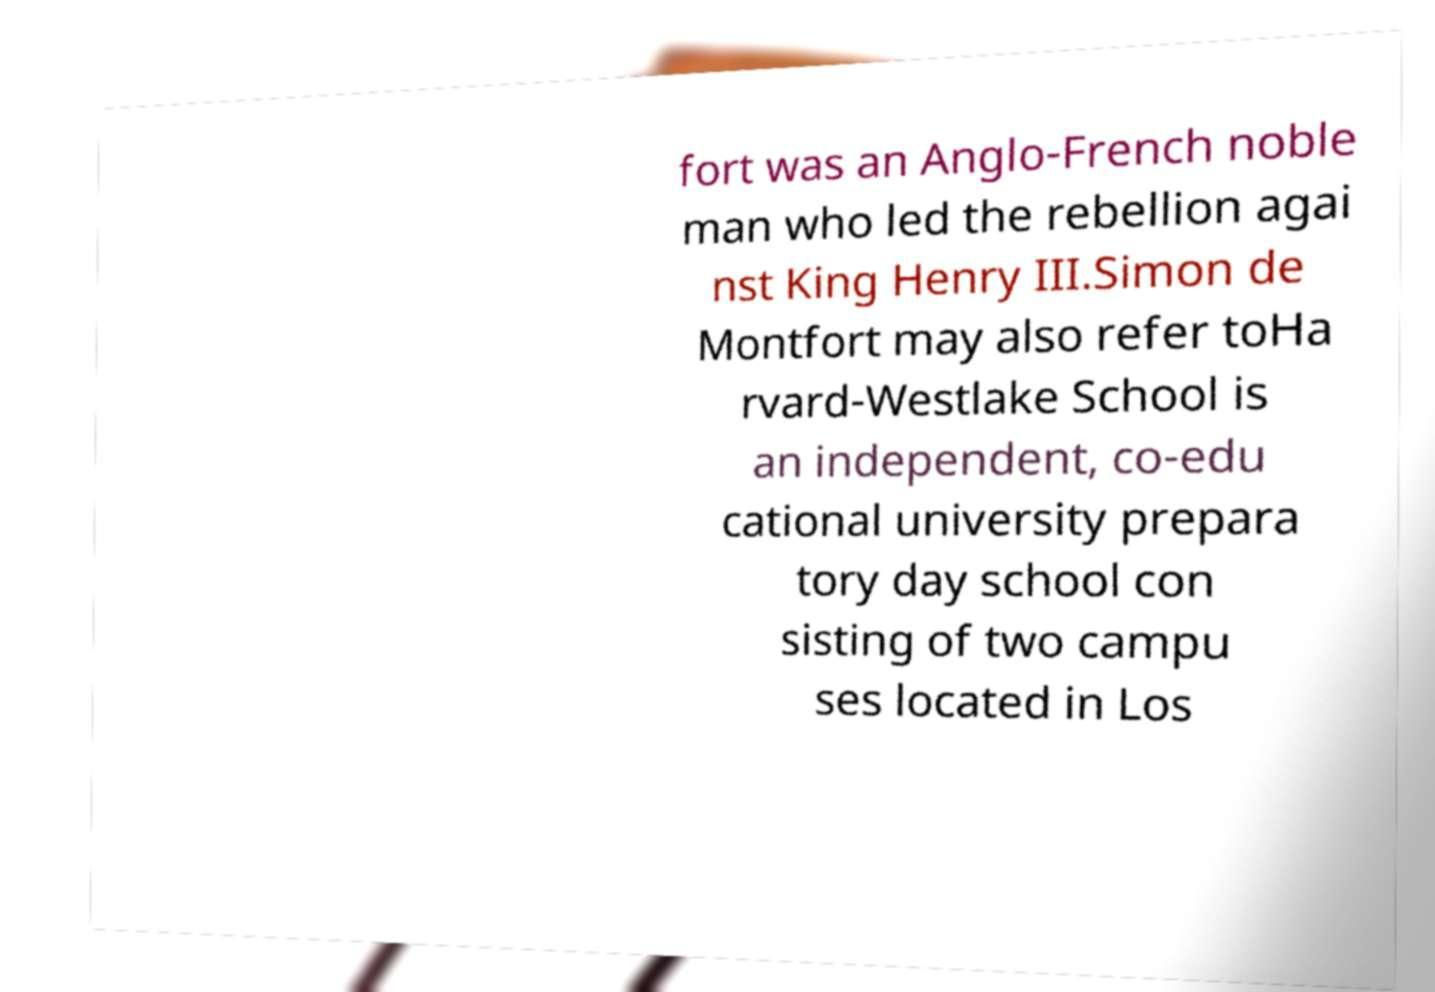Please read and relay the text visible in this image. What does it say? fort was an Anglo-French noble man who led the rebellion agai nst King Henry III.Simon de Montfort may also refer toHa rvard-Westlake School is an independent, co-edu cational university prepara tory day school con sisting of two campu ses located in Los 